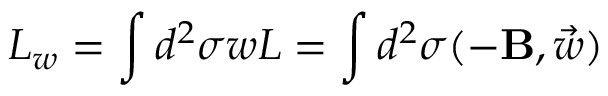<formula> <loc_0><loc_0><loc_500><loc_500>L _ { w } = \int d ^ { 2 } \sigma w L = \int d ^ { 2 } \sigma ( - { B } , \vec { w } )</formula> 